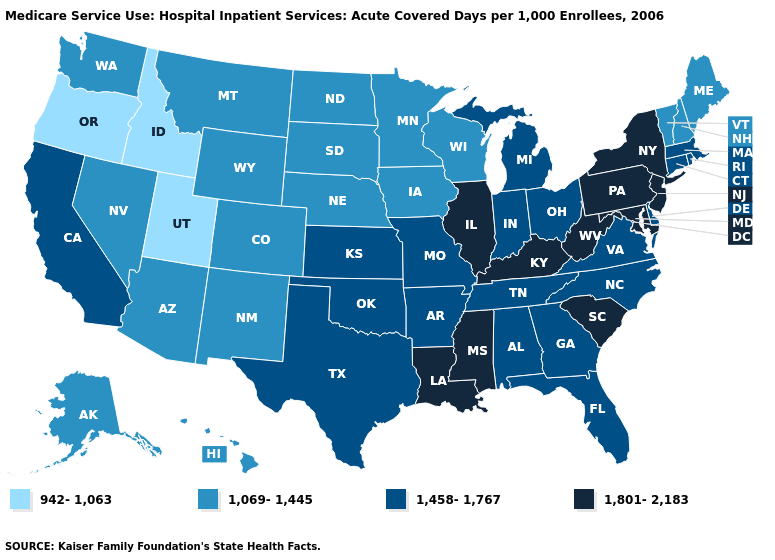Name the states that have a value in the range 1,458-1,767?
Short answer required. Alabama, Arkansas, California, Connecticut, Delaware, Florida, Georgia, Indiana, Kansas, Massachusetts, Michigan, Missouri, North Carolina, Ohio, Oklahoma, Rhode Island, Tennessee, Texas, Virginia. What is the highest value in states that border California?
Concise answer only. 1,069-1,445. Name the states that have a value in the range 1,069-1,445?
Write a very short answer. Alaska, Arizona, Colorado, Hawaii, Iowa, Maine, Minnesota, Montana, Nebraska, Nevada, New Hampshire, New Mexico, North Dakota, South Dakota, Vermont, Washington, Wisconsin, Wyoming. Does the first symbol in the legend represent the smallest category?
Short answer required. Yes. What is the value of Tennessee?
Answer briefly. 1,458-1,767. Is the legend a continuous bar?
Short answer required. No. Does the first symbol in the legend represent the smallest category?
Write a very short answer. Yes. Name the states that have a value in the range 942-1,063?
Keep it brief. Idaho, Oregon, Utah. Name the states that have a value in the range 1,069-1,445?
Give a very brief answer. Alaska, Arizona, Colorado, Hawaii, Iowa, Maine, Minnesota, Montana, Nebraska, Nevada, New Hampshire, New Mexico, North Dakota, South Dakota, Vermont, Washington, Wisconsin, Wyoming. What is the value of Hawaii?
Be succinct. 1,069-1,445. Does Utah have a higher value than Montana?
Short answer required. No. Does Arizona have the highest value in the USA?
Quick response, please. No. Does California have the highest value in the West?
Give a very brief answer. Yes. Does Missouri have a lower value than Colorado?
Be succinct. No. Which states have the highest value in the USA?
Be succinct. Illinois, Kentucky, Louisiana, Maryland, Mississippi, New Jersey, New York, Pennsylvania, South Carolina, West Virginia. 